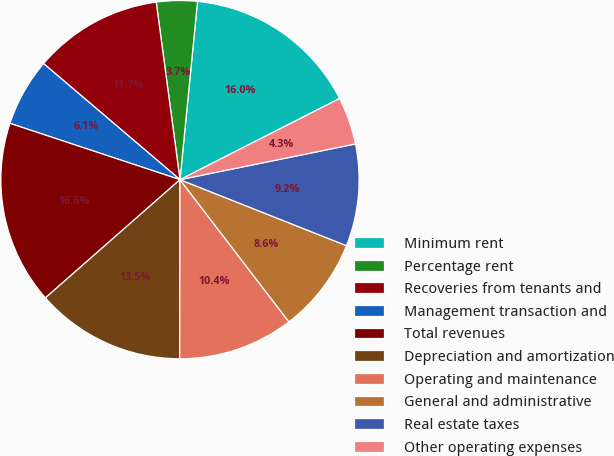Convert chart. <chart><loc_0><loc_0><loc_500><loc_500><pie_chart><fcel>Minimum rent<fcel>Percentage rent<fcel>Recoveries from tenants and<fcel>Management transaction and<fcel>Total revenues<fcel>Depreciation and amortization<fcel>Operating and maintenance<fcel>General and administrative<fcel>Real estate taxes<fcel>Other operating expenses<nl><fcel>15.95%<fcel>3.68%<fcel>11.66%<fcel>6.13%<fcel>16.56%<fcel>13.5%<fcel>10.43%<fcel>8.59%<fcel>9.2%<fcel>4.29%<nl></chart> 